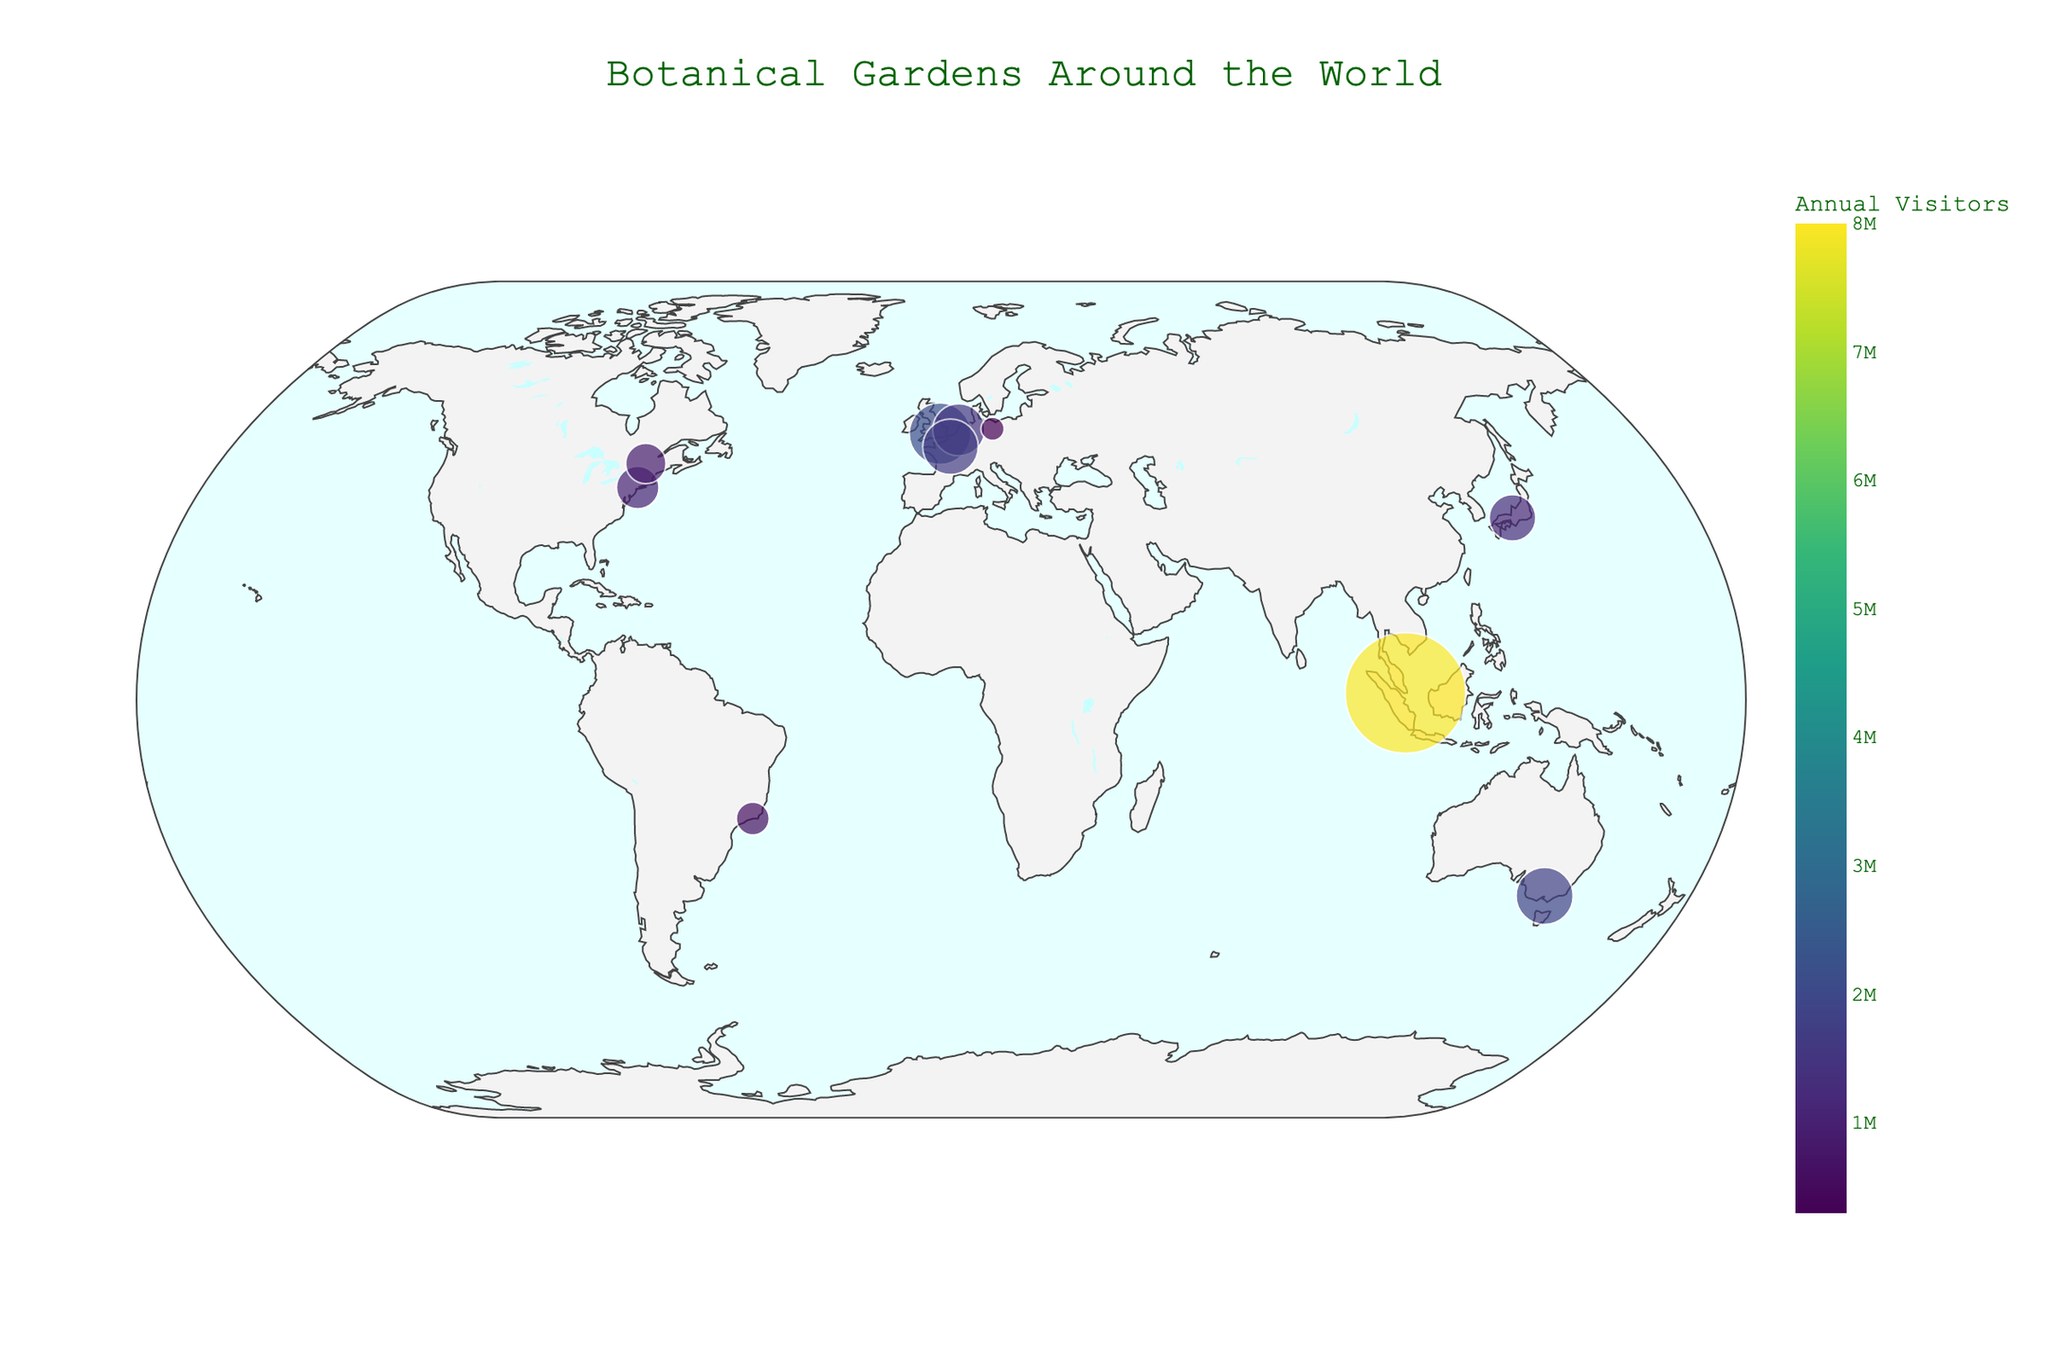What is the title of the plot? The title of the plot is usually shown at the top center of the figure.
Answer: Botanical Gardens Around the World Which botanical garden has the highest number of annual visitors? Look for the largest data point on the plot, and check the hover text to find the botanical garden's name.
Answer: Gardens by the Bay How many botanical gardens have annual visitors above 1 million? Look at the size and color of the data points. Count the points with relatively large size, and check the hover text to ensure they have over 1 million visitors.
Answer: 7 Which country has the botanical garden with the fewest annual visitors? Identify the smallest data point and refer to the hover text or the legend to find its country.
Answer: Germany Among the botanical gardens listed, which one is located at the highest latitude? Find the data point with the highest latitude value (farthest north) on the plot. Check its hover text for the garden's name.
Answer: Montreal Botanical Garden What is the total number of annual visitors for all the botanical gardens in the plot? Add up the annual visitors from each data point.
Answer: 18,000,000 Compare the number of visitors between Royal Botanic Gardens Kew and Jardim Botânico do Rio de Janeiro. Find the two data points and refer to their hover text for the visitor numbers, then compare them.
Answer: Royal Botanic Gardens Kew has more visitors Which botanical garden in the Southern Hemisphere has the highest number of annual visitors? Identify data points in the Southern Hemisphere (latitudes below 0) and check their visitor numbers.
Answer: Royal Botanic Gardens Victoria How many continents are represented in this botanical garden distribution plot? Look at the geographic distribution of the data points and count the represented continents.
Answer: 5 What is the color scale used to represent the annual visitors? Observe the color bar on the plot to understand the mapping of colors to visitor numbers.
Answer: Viridis 